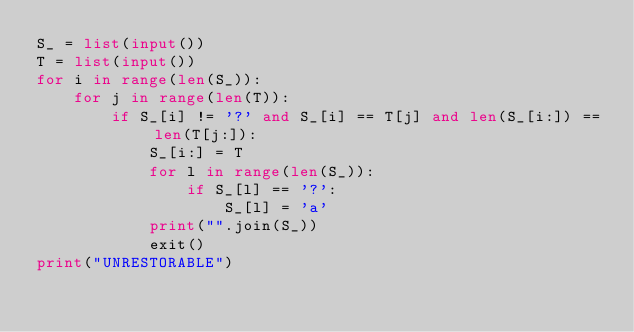Convert code to text. <code><loc_0><loc_0><loc_500><loc_500><_Python_>S_ = list(input())
T = list(input())
for i in range(len(S_)):
    for j in range(len(T)):
        if S_[i] != '?' and S_[i] == T[j] and len(S_[i:]) == len(T[j:]):
            S_[i:] = T
            for l in range(len(S_)):
                if S_[l] == '?':
                    S_[l] = 'a'
            print("".join(S_))
            exit()
print("UNRESTORABLE")</code> 